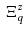Convert formula to latex. <formula><loc_0><loc_0><loc_500><loc_500>\Xi _ { q } ^ { z }</formula> 